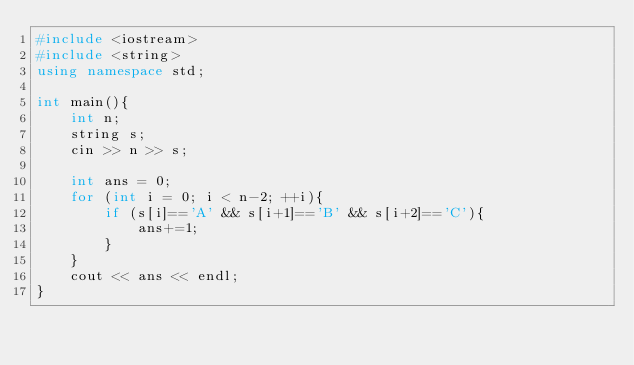<code> <loc_0><loc_0><loc_500><loc_500><_C++_>#include <iostream>
#include <string>
using namespace std;

int main(){
    int n;
    string s;
    cin >> n >> s;

    int ans = 0;
    for (int i = 0; i < n-2; ++i){
        if (s[i]=='A' && s[i+1]=='B' && s[i+2]=='C'){
            ans+=1;
        }
    }
    cout << ans << endl;
}</code> 